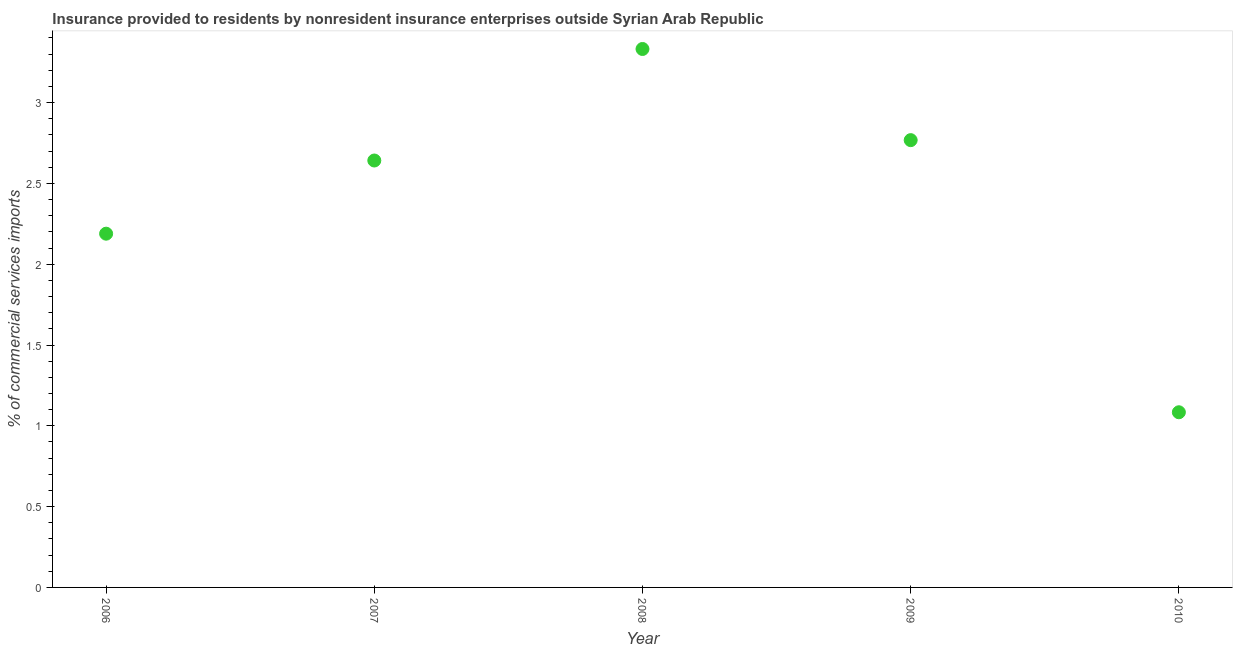What is the insurance provided by non-residents in 2008?
Offer a terse response. 3.33. Across all years, what is the maximum insurance provided by non-residents?
Your answer should be very brief. 3.33. Across all years, what is the minimum insurance provided by non-residents?
Offer a terse response. 1.08. In which year was the insurance provided by non-residents maximum?
Keep it short and to the point. 2008. In which year was the insurance provided by non-residents minimum?
Offer a terse response. 2010. What is the sum of the insurance provided by non-residents?
Give a very brief answer. 12.01. What is the difference between the insurance provided by non-residents in 2008 and 2010?
Offer a terse response. 2.25. What is the average insurance provided by non-residents per year?
Provide a short and direct response. 2.4. What is the median insurance provided by non-residents?
Make the answer very short. 2.64. In how many years, is the insurance provided by non-residents greater than 0.5 %?
Provide a succinct answer. 5. Do a majority of the years between 2009 and 2008 (inclusive) have insurance provided by non-residents greater than 1.4 %?
Offer a terse response. No. What is the ratio of the insurance provided by non-residents in 2007 to that in 2010?
Offer a terse response. 2.44. What is the difference between the highest and the second highest insurance provided by non-residents?
Give a very brief answer. 0.56. Is the sum of the insurance provided by non-residents in 2006 and 2008 greater than the maximum insurance provided by non-residents across all years?
Your answer should be compact. Yes. What is the difference between the highest and the lowest insurance provided by non-residents?
Your answer should be very brief. 2.25. Does the insurance provided by non-residents monotonically increase over the years?
Offer a very short reply. No. How many dotlines are there?
Ensure brevity in your answer.  1. Does the graph contain any zero values?
Keep it short and to the point. No. What is the title of the graph?
Your answer should be very brief. Insurance provided to residents by nonresident insurance enterprises outside Syrian Arab Republic. What is the label or title of the X-axis?
Offer a very short reply. Year. What is the label or title of the Y-axis?
Keep it short and to the point. % of commercial services imports. What is the % of commercial services imports in 2006?
Provide a succinct answer. 2.19. What is the % of commercial services imports in 2007?
Keep it short and to the point. 2.64. What is the % of commercial services imports in 2008?
Offer a terse response. 3.33. What is the % of commercial services imports in 2009?
Provide a short and direct response. 2.77. What is the % of commercial services imports in 2010?
Give a very brief answer. 1.08. What is the difference between the % of commercial services imports in 2006 and 2007?
Make the answer very short. -0.45. What is the difference between the % of commercial services imports in 2006 and 2008?
Provide a short and direct response. -1.14. What is the difference between the % of commercial services imports in 2006 and 2009?
Keep it short and to the point. -0.58. What is the difference between the % of commercial services imports in 2006 and 2010?
Give a very brief answer. 1.1. What is the difference between the % of commercial services imports in 2007 and 2008?
Offer a terse response. -0.69. What is the difference between the % of commercial services imports in 2007 and 2009?
Provide a short and direct response. -0.13. What is the difference between the % of commercial services imports in 2007 and 2010?
Provide a short and direct response. 1.56. What is the difference between the % of commercial services imports in 2008 and 2009?
Your answer should be compact. 0.56. What is the difference between the % of commercial services imports in 2008 and 2010?
Ensure brevity in your answer.  2.25. What is the difference between the % of commercial services imports in 2009 and 2010?
Give a very brief answer. 1.68. What is the ratio of the % of commercial services imports in 2006 to that in 2007?
Your response must be concise. 0.83. What is the ratio of the % of commercial services imports in 2006 to that in 2008?
Ensure brevity in your answer.  0.66. What is the ratio of the % of commercial services imports in 2006 to that in 2009?
Offer a very short reply. 0.79. What is the ratio of the % of commercial services imports in 2006 to that in 2010?
Offer a terse response. 2.02. What is the ratio of the % of commercial services imports in 2007 to that in 2008?
Provide a short and direct response. 0.79. What is the ratio of the % of commercial services imports in 2007 to that in 2009?
Your answer should be compact. 0.95. What is the ratio of the % of commercial services imports in 2007 to that in 2010?
Provide a short and direct response. 2.44. What is the ratio of the % of commercial services imports in 2008 to that in 2009?
Your response must be concise. 1.2. What is the ratio of the % of commercial services imports in 2008 to that in 2010?
Make the answer very short. 3.07. What is the ratio of the % of commercial services imports in 2009 to that in 2010?
Provide a short and direct response. 2.55. 